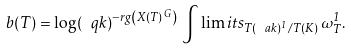<formula> <loc_0><loc_0><loc_500><loc_500>b ( T ) = \log ( \ q k ) ^ { - r g \left ( X ( T ) ^ { \, G } \right ) } \, \int \lim i t s _ { T ( \ a k ) ^ { 1 } / T ( K ) } \, \omega _ { T } ^ { 1 } .</formula> 